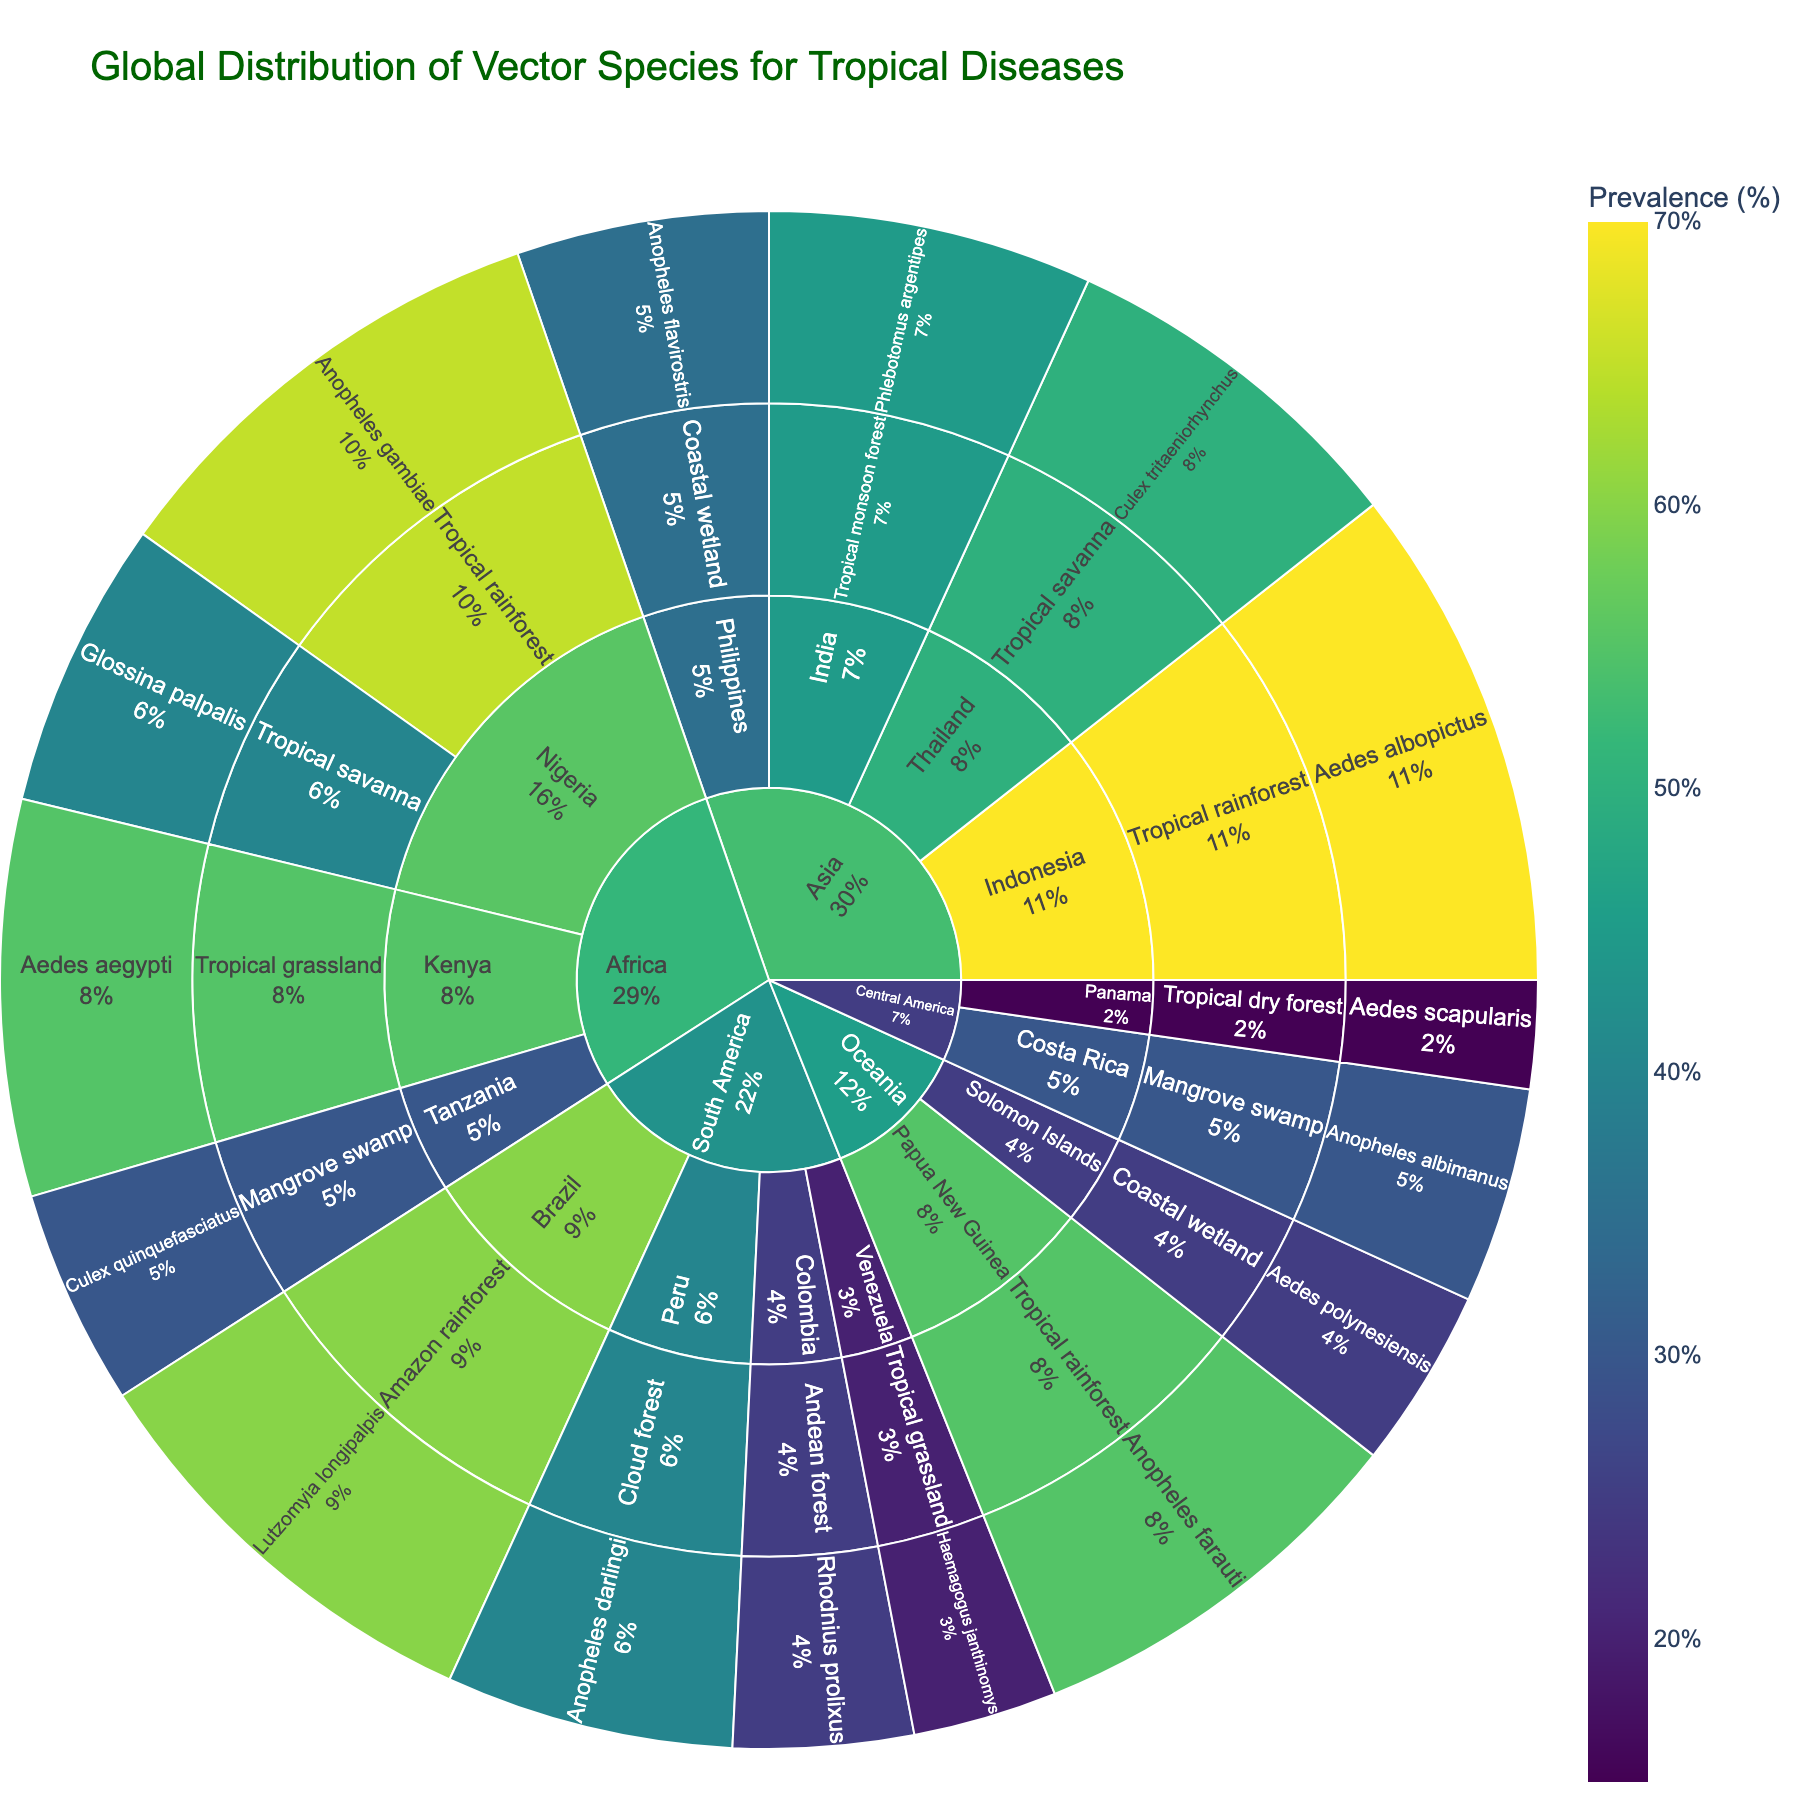what is the title of the sunburst plot? The title can be seen at the top of the plot. It provides information about what the plot represents.
Answer: Global Distribution of Vector Species for Tropical Diseases In which country is *Anopheles gambiae* prevalent, and what is the ecosystem? Look at the segments for the vector species and trace back to the country and ecosystem. *Anopheles gambiae* is under Nigeria, found in the Tropical rainforest ecosystem.
Answer: Nigeria, Tropical rainforest How many different ecosystem types are present in South America? Identify all the unique ecosystem segments under the South America segment.
Answer: 4 Which vector species has the highest prevalence in Asia, and what is the value? Trace the paths under Asia to find the vector species with the highest prevalence value. *Aedes albopictus* in Indonesia has the highest prevalence of 70%.
Answer: Aedes albopictus, 70% What is the combined prevalence of vector species in Africa? Sum up the prevalence values for all vector species found under the Africa segment: 65 (Anopheles gambiae) + 40 (Glossina palpalis) + 55 (Aedes aegypti) + 30 (Culex quinquefasciatus).
Answer: 190% Compare the prevalence of *Anopheles flavirostris* in the Philippines and *Aedes polynesiensis* in the Solomon Islands. Which has a higher prevalence? Compare the numerical values of prevalence for both species. *Anopheles flavirostris* has 35%, and *Aedes polynesiensis* has 25%.
Answer: Anopheles flavirostris Which continent has a vector species with the lowest prevalence? Identify the lowest prevalence value across all continents and find the corresponding continent. *Aedes scapularis* in Panama (Central America) has the lowest prevalence of 15%.
Answer: Central America What percentage of ecosystems in Oceania have more than 25% prevalence for their vector species? Identify the ecosystems in Oceania and their respective prevalence values. Both *Anopheles farauti* (55%) and *Aedes polynesiensis* (25%) are the species; only one meets the criterion. There are 2 ecosystems, and 1 has more than 25%. Calculate 1/2 = 50%.
Answer: 50% Which vector species is found in the Andean forest, and what is its prevalence? Navigate the plot to the Andean forest under South America and identify the species. *Rhodnius prolixus* is found, with a prevalence of 25%.
Answer: Rhodnius prolixus, 25% What is the average prevalence of vector species in Central America? Calculate the average of prevalence values: (15 + 30) / 2.
Answer: 22.5% 